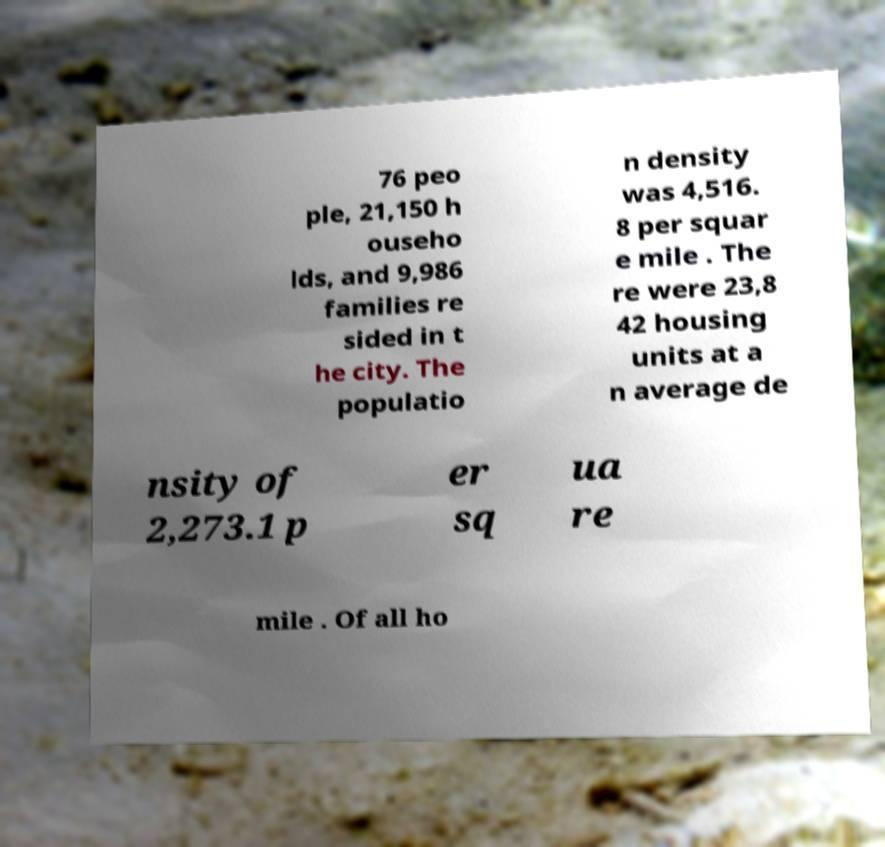What messages or text are displayed in this image? I need them in a readable, typed format. 76 peo ple, 21,150 h ouseho lds, and 9,986 families re sided in t he city. The populatio n density was 4,516. 8 per squar e mile . The re were 23,8 42 housing units at a n average de nsity of 2,273.1 p er sq ua re mile . Of all ho 